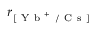<formula> <loc_0><loc_0><loc_500><loc_500>r _ { [ Y b ^ { + } / C s ] }</formula> 